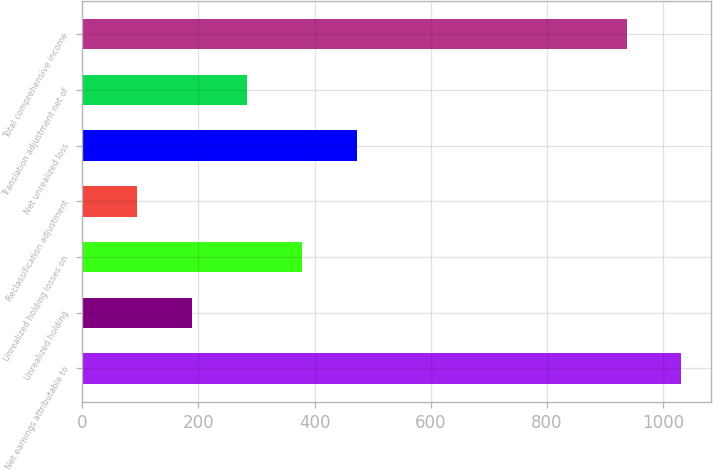Convert chart to OTSL. <chart><loc_0><loc_0><loc_500><loc_500><bar_chart><fcel>Net earnings attributable to<fcel>Unrealized holding<fcel>Unrealized holding losses on<fcel>Reclassification adjustment<fcel>Net unrealized loss<fcel>Translation adjustment net of<fcel>Total comprehensive income<nl><fcel>1031.94<fcel>189.28<fcel>378.36<fcel>94.74<fcel>472.9<fcel>283.82<fcel>937.4<nl></chart> 